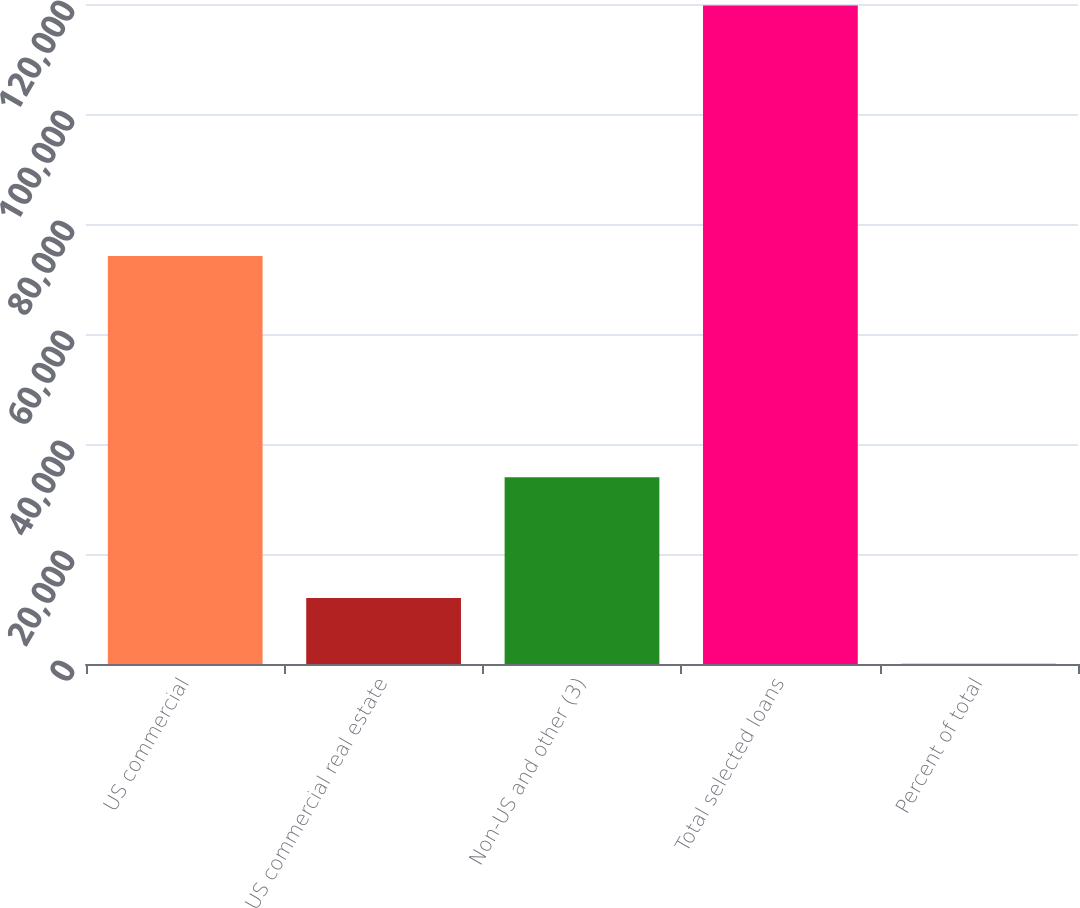Convert chart. <chart><loc_0><loc_0><loc_500><loc_500><bar_chart><fcel>US commercial<fcel>US commercial real estate<fcel>Non-US and other (3)<fcel>Total selected loans<fcel>Percent of total<nl><fcel>74191<fcel>11996<fcel>33971<fcel>119717<fcel>27<nl></chart> 